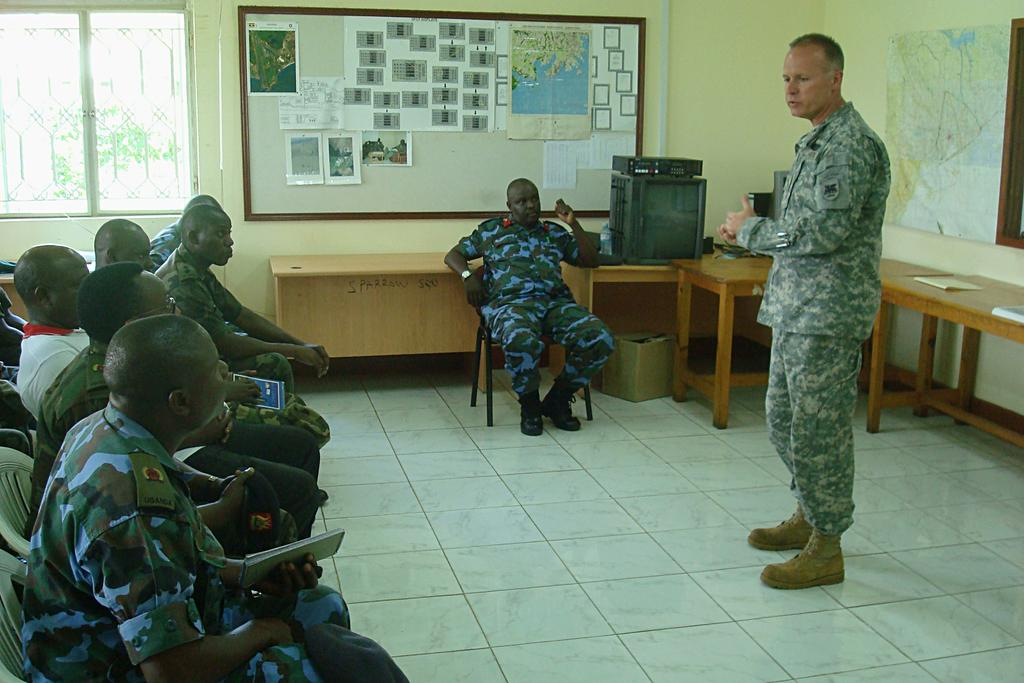What are the people in the image doing? There is a group of people seated in the image. What is the man in the image doing? There is a man standing and speaking in the image. What type of furniture is present in the image? There are chairs, tables, and a notice board in the image. What is hanging on the wall in the image? There is a map on the wall in the image. What type of engine is visible on the canvas in the image? There is no engine or canvas present in the image. How many brothers are standing next to the map in the image? There is no mention of brothers in the image, and only one man is standing and speaking. 